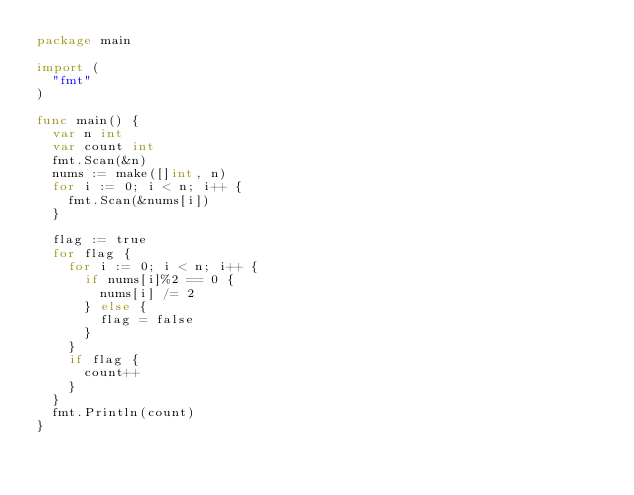<code> <loc_0><loc_0><loc_500><loc_500><_Go_>package main

import (
	"fmt"
)

func main() {
	var n int
	var count int
	fmt.Scan(&n)
	nums := make([]int, n)
	for i := 0; i < n; i++ {
		fmt.Scan(&nums[i])
	}

	flag := true
	for flag {
		for i := 0; i < n; i++ {
			if nums[i]%2 == 0 {
				nums[i] /= 2
			} else {
				flag = false
			}
		}
		if flag {
			count++
		}
	}
	fmt.Println(count)
}</code> 